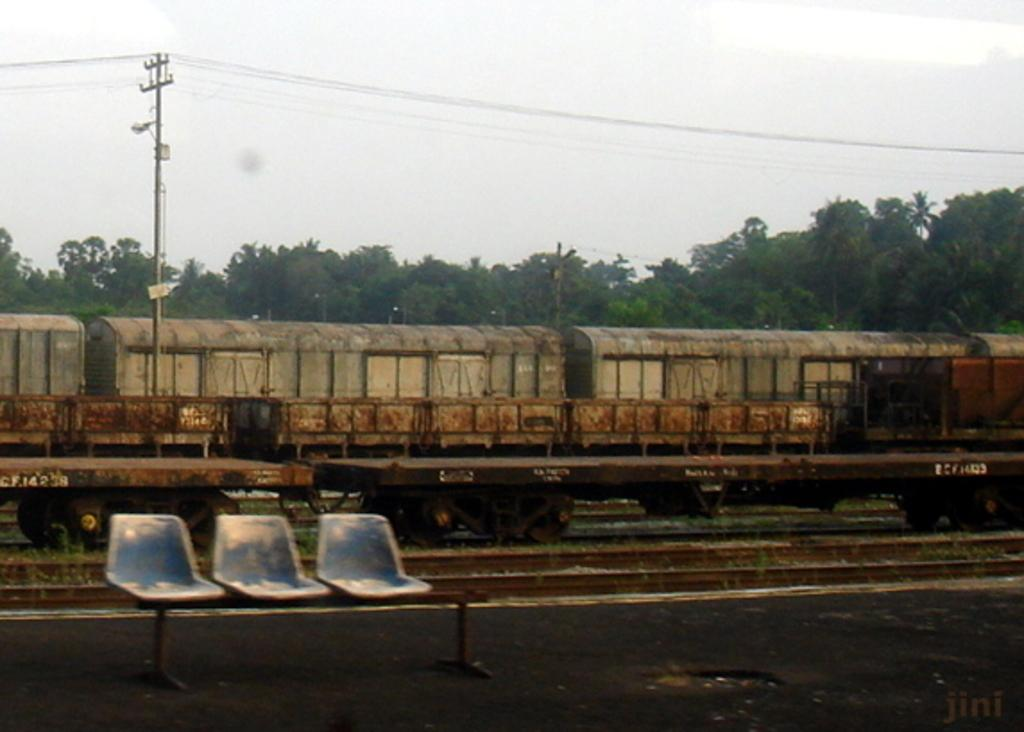What can be seen in the distance in the image? There are multiple trees in the distance. What type of vehicle is present in the image? There is a goods train on a track. How many chairs are visible in the front of the image? There are three chairs in the front of the image. What is the color of the sky in the image? The sky appears to be white in color. What utility infrastructure is present in the image? There is a current pole with cables in the image. Where is the nail used to hang the kettle in the image? There is no nail or kettle present in the image. What type of bag is visible on the chairs in the image? There are no bags visible on the chairs in the image. 